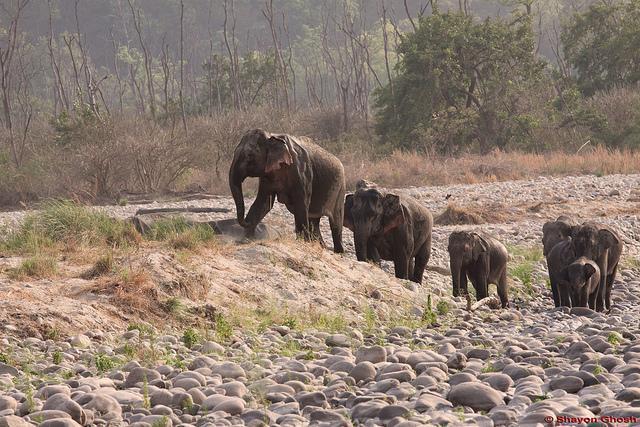How many elephants are there?
Give a very brief answer. 4. How many people holding umbrellas are in the picture?
Give a very brief answer. 0. 